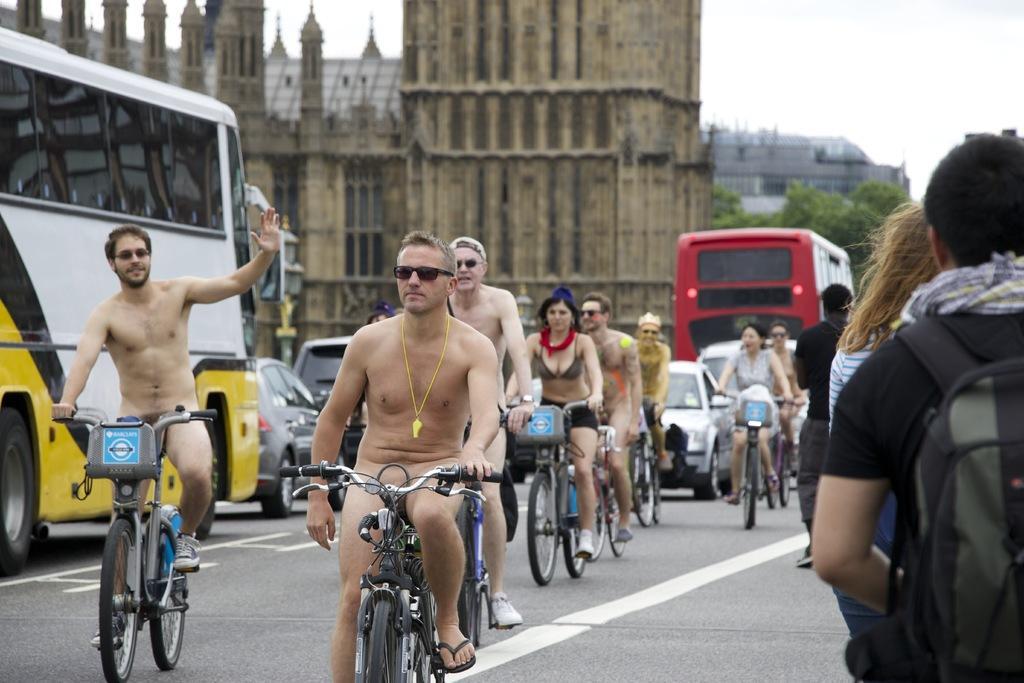Can you describe this image briefly? In this picture there are group of people, it seems to be a view of road and all are cycling on the road, there are buildings at the back side of the image, there is a bus at the left side of the image and there is a group of people those who are walking at the right side of the image. 